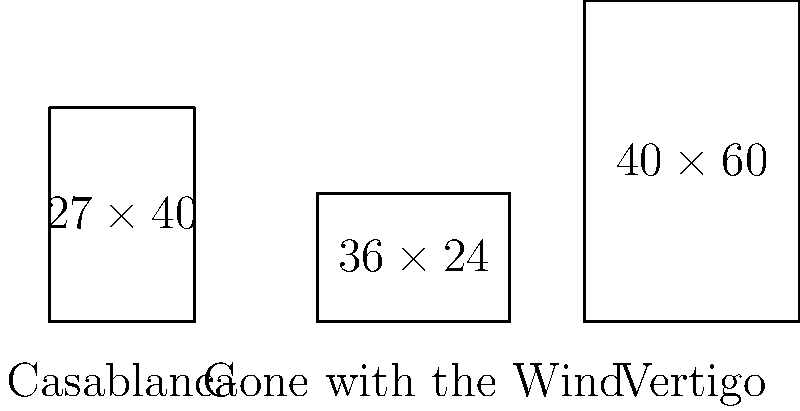As a film buff creating artwork inspired by classic movies, you're designing a series of movie posters. Given the dimensions of three iconic film posters shown above, calculate the aspect ratio (width:height) of each poster and determine which one has the widest aspect ratio. Express your final answer as the title of the movie with the widest aspect ratio. To solve this problem, we need to calculate the aspect ratio for each movie poster and compare them. The aspect ratio is expressed as width:height.

1. Casablanca:
   Dimensions: 27 × 40
   Aspect ratio = $\frac{27}{40} = 0.675:1$

2. Gone with the Wind:
   Dimensions: 36 × 24
   Aspect ratio = $\frac{36}{24} = 1.5:1$

3. Vertigo:
   Dimensions: 40 × 60
   Aspect ratio = $\frac{40}{60} = \frac{2}{3} = 0.667:1$

Comparing the aspect ratios:
Casablanca: 0.675:1
Gone with the Wind: 1.5:1
Vertigo: 0.667:1

The widest aspect ratio is 1.5:1, which corresponds to "Gone with the Wind".
Answer: Gone with the Wind 